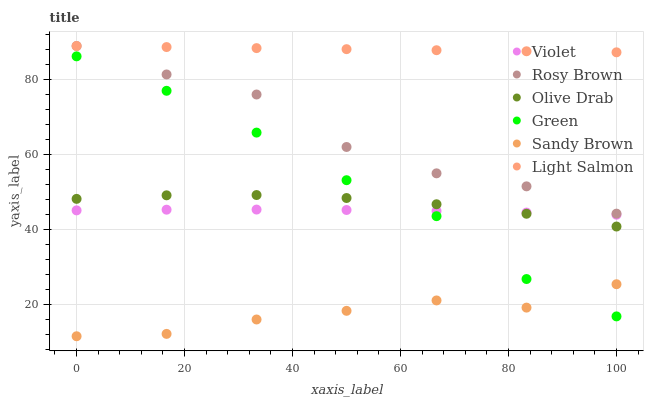Does Sandy Brown have the minimum area under the curve?
Answer yes or no. Yes. Does Light Salmon have the maximum area under the curve?
Answer yes or no. Yes. Does Rosy Brown have the minimum area under the curve?
Answer yes or no. No. Does Rosy Brown have the maximum area under the curve?
Answer yes or no. No. Is Light Salmon the smoothest?
Answer yes or no. Yes. Is Rosy Brown the roughest?
Answer yes or no. Yes. Is Green the smoothest?
Answer yes or no. No. Is Green the roughest?
Answer yes or no. No. Does Sandy Brown have the lowest value?
Answer yes or no. Yes. Does Rosy Brown have the lowest value?
Answer yes or no. No. Does Rosy Brown have the highest value?
Answer yes or no. Yes. Does Green have the highest value?
Answer yes or no. No. Is Sandy Brown less than Light Salmon?
Answer yes or no. Yes. Is Rosy Brown greater than Olive Drab?
Answer yes or no. Yes. Does Sandy Brown intersect Green?
Answer yes or no. Yes. Is Sandy Brown less than Green?
Answer yes or no. No. Is Sandy Brown greater than Green?
Answer yes or no. No. Does Sandy Brown intersect Light Salmon?
Answer yes or no. No. 